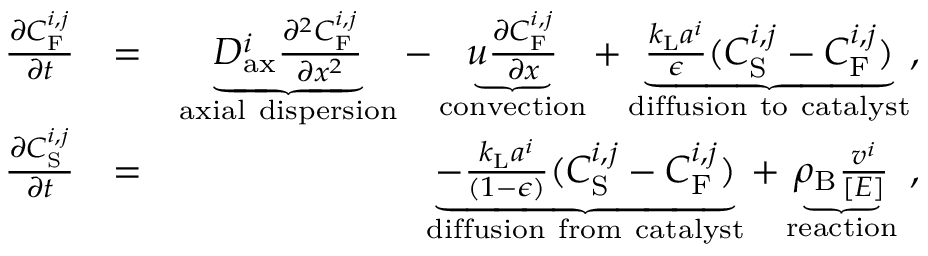Convert formula to latex. <formula><loc_0><loc_0><loc_500><loc_500>\begin{array} { r l r } { \frac { \partial C _ { F } ^ { i , j } } { \partial t } } & { = } & { \underbrace { D _ { a x } ^ { i } \frac { \partial ^ { 2 } C _ { F } ^ { i , j } } { \partial x ^ { 2 } } } _ { a x i a l d i s p e r s i o n } - \underbrace { u \frac { \partial C _ { F } ^ { i , j } } { \partial x } } _ { c o n v e c t i o n } + \underbrace { \frac { k _ { L } a ^ { i } } { \epsilon } ( C _ { S } ^ { i , j } - C _ { F } ^ { i , j } ) } _ { d i f f u s i o n t o c a t a l y s t } , } \\ { \frac { \partial C _ { S } ^ { i , j } } { \partial t } } & { = } & { \underbrace { - \frac { k _ { L } a ^ { i } } { ( 1 - \epsilon ) } ( C _ { S } ^ { i , j } - C _ { F } ^ { i , j } ) } _ { d i f f u s i o n f r o m c a t a l y s t } + \underbrace { \rho _ { B } \frac { v ^ { i } } { [ E ] } } _ { r e a c t i o n } \ , } \end{array}</formula> 